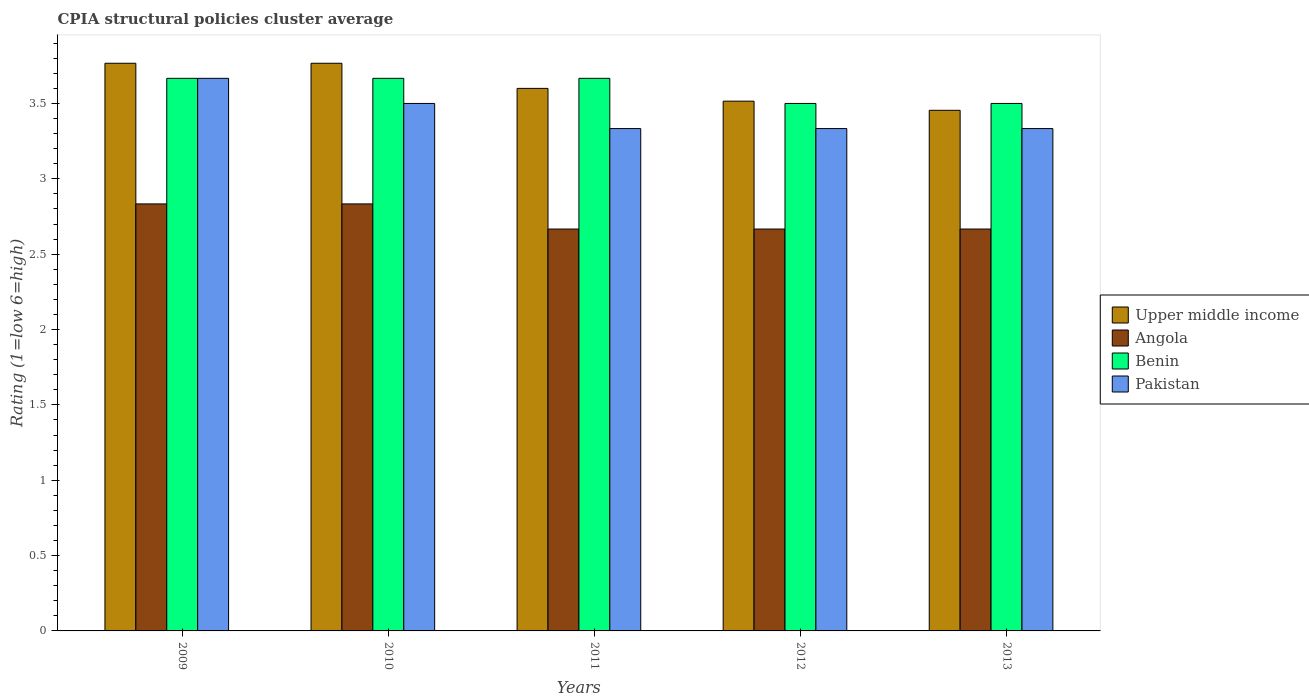How many different coloured bars are there?
Your response must be concise. 4. Are the number of bars per tick equal to the number of legend labels?
Your response must be concise. Yes. In how many cases, is the number of bars for a given year not equal to the number of legend labels?
Keep it short and to the point. 0. What is the CPIA rating in Angola in 2009?
Your answer should be very brief. 2.83. Across all years, what is the maximum CPIA rating in Angola?
Offer a terse response. 2.83. Across all years, what is the minimum CPIA rating in Upper middle income?
Provide a succinct answer. 3.45. In which year was the CPIA rating in Benin minimum?
Offer a terse response. 2012. What is the total CPIA rating in Upper middle income in the graph?
Give a very brief answer. 18.1. What is the difference between the CPIA rating in Angola in 2009 and that in 2013?
Keep it short and to the point. 0.17. What is the average CPIA rating in Pakistan per year?
Provide a short and direct response. 3.43. In the year 2009, what is the difference between the CPIA rating in Angola and CPIA rating in Benin?
Provide a succinct answer. -0.83. What is the ratio of the CPIA rating in Angola in 2011 to that in 2013?
Ensure brevity in your answer.  1. Is the CPIA rating in Angola in 2012 less than that in 2013?
Give a very brief answer. No. Is the difference between the CPIA rating in Angola in 2009 and 2010 greater than the difference between the CPIA rating in Benin in 2009 and 2010?
Provide a succinct answer. No. What is the difference between the highest and the lowest CPIA rating in Upper middle income?
Keep it short and to the point. 0.31. What does the 3rd bar from the left in 2011 represents?
Make the answer very short. Benin. What does the 3rd bar from the right in 2011 represents?
Your response must be concise. Angola. Is it the case that in every year, the sum of the CPIA rating in Benin and CPIA rating in Angola is greater than the CPIA rating in Pakistan?
Provide a short and direct response. Yes. What is the difference between two consecutive major ticks on the Y-axis?
Give a very brief answer. 0.5. Does the graph contain grids?
Your response must be concise. No. Where does the legend appear in the graph?
Ensure brevity in your answer.  Center right. How are the legend labels stacked?
Your answer should be compact. Vertical. What is the title of the graph?
Ensure brevity in your answer.  CPIA structural policies cluster average. What is the label or title of the X-axis?
Ensure brevity in your answer.  Years. What is the label or title of the Y-axis?
Your response must be concise. Rating (1=low 6=high). What is the Rating (1=low 6=high) in Upper middle income in 2009?
Ensure brevity in your answer.  3.77. What is the Rating (1=low 6=high) of Angola in 2009?
Your response must be concise. 2.83. What is the Rating (1=low 6=high) in Benin in 2009?
Provide a short and direct response. 3.67. What is the Rating (1=low 6=high) in Pakistan in 2009?
Your answer should be compact. 3.67. What is the Rating (1=low 6=high) in Upper middle income in 2010?
Your response must be concise. 3.77. What is the Rating (1=low 6=high) of Angola in 2010?
Offer a terse response. 2.83. What is the Rating (1=low 6=high) of Benin in 2010?
Provide a succinct answer. 3.67. What is the Rating (1=low 6=high) of Angola in 2011?
Offer a terse response. 2.67. What is the Rating (1=low 6=high) of Benin in 2011?
Offer a terse response. 3.67. What is the Rating (1=low 6=high) in Pakistan in 2011?
Offer a terse response. 3.33. What is the Rating (1=low 6=high) of Upper middle income in 2012?
Your answer should be very brief. 3.52. What is the Rating (1=low 6=high) of Angola in 2012?
Provide a short and direct response. 2.67. What is the Rating (1=low 6=high) in Benin in 2012?
Offer a terse response. 3.5. What is the Rating (1=low 6=high) in Pakistan in 2012?
Make the answer very short. 3.33. What is the Rating (1=low 6=high) of Upper middle income in 2013?
Keep it short and to the point. 3.45. What is the Rating (1=low 6=high) of Angola in 2013?
Make the answer very short. 2.67. What is the Rating (1=low 6=high) of Pakistan in 2013?
Your answer should be very brief. 3.33. Across all years, what is the maximum Rating (1=low 6=high) of Upper middle income?
Make the answer very short. 3.77. Across all years, what is the maximum Rating (1=low 6=high) of Angola?
Offer a terse response. 2.83. Across all years, what is the maximum Rating (1=low 6=high) of Benin?
Give a very brief answer. 3.67. Across all years, what is the maximum Rating (1=low 6=high) in Pakistan?
Offer a very short reply. 3.67. Across all years, what is the minimum Rating (1=low 6=high) in Upper middle income?
Your answer should be compact. 3.45. Across all years, what is the minimum Rating (1=low 6=high) of Angola?
Keep it short and to the point. 2.67. Across all years, what is the minimum Rating (1=low 6=high) of Benin?
Give a very brief answer. 3.5. Across all years, what is the minimum Rating (1=low 6=high) in Pakistan?
Make the answer very short. 3.33. What is the total Rating (1=low 6=high) of Upper middle income in the graph?
Provide a short and direct response. 18.1. What is the total Rating (1=low 6=high) of Angola in the graph?
Provide a short and direct response. 13.67. What is the total Rating (1=low 6=high) in Pakistan in the graph?
Offer a terse response. 17.17. What is the difference between the Rating (1=low 6=high) of Angola in 2009 and that in 2010?
Make the answer very short. 0. What is the difference between the Rating (1=low 6=high) of Benin in 2009 and that in 2010?
Offer a terse response. 0. What is the difference between the Rating (1=low 6=high) in Pakistan in 2009 and that in 2010?
Your response must be concise. 0.17. What is the difference between the Rating (1=low 6=high) in Upper middle income in 2009 and that in 2012?
Give a very brief answer. 0.25. What is the difference between the Rating (1=low 6=high) in Pakistan in 2009 and that in 2012?
Ensure brevity in your answer.  0.33. What is the difference between the Rating (1=low 6=high) of Upper middle income in 2009 and that in 2013?
Provide a succinct answer. 0.31. What is the difference between the Rating (1=low 6=high) in Angola in 2009 and that in 2013?
Your answer should be very brief. 0.17. What is the difference between the Rating (1=low 6=high) in Pakistan in 2009 and that in 2013?
Provide a short and direct response. 0.33. What is the difference between the Rating (1=low 6=high) in Upper middle income in 2010 and that in 2011?
Give a very brief answer. 0.17. What is the difference between the Rating (1=low 6=high) in Pakistan in 2010 and that in 2011?
Offer a terse response. 0.17. What is the difference between the Rating (1=low 6=high) of Upper middle income in 2010 and that in 2012?
Provide a short and direct response. 0.25. What is the difference between the Rating (1=low 6=high) in Angola in 2010 and that in 2012?
Keep it short and to the point. 0.17. What is the difference between the Rating (1=low 6=high) of Upper middle income in 2010 and that in 2013?
Your answer should be compact. 0.31. What is the difference between the Rating (1=low 6=high) in Angola in 2010 and that in 2013?
Give a very brief answer. 0.17. What is the difference between the Rating (1=low 6=high) of Benin in 2010 and that in 2013?
Your answer should be compact. 0.17. What is the difference between the Rating (1=low 6=high) in Pakistan in 2010 and that in 2013?
Provide a short and direct response. 0.17. What is the difference between the Rating (1=low 6=high) in Upper middle income in 2011 and that in 2012?
Provide a short and direct response. 0.08. What is the difference between the Rating (1=low 6=high) in Angola in 2011 and that in 2012?
Make the answer very short. 0. What is the difference between the Rating (1=low 6=high) in Benin in 2011 and that in 2012?
Provide a short and direct response. 0.17. What is the difference between the Rating (1=low 6=high) of Upper middle income in 2011 and that in 2013?
Provide a succinct answer. 0.15. What is the difference between the Rating (1=low 6=high) in Angola in 2011 and that in 2013?
Offer a terse response. 0. What is the difference between the Rating (1=low 6=high) of Benin in 2011 and that in 2013?
Offer a terse response. 0.17. What is the difference between the Rating (1=low 6=high) in Upper middle income in 2012 and that in 2013?
Your answer should be very brief. 0.06. What is the difference between the Rating (1=low 6=high) of Angola in 2012 and that in 2013?
Make the answer very short. 0. What is the difference between the Rating (1=low 6=high) of Pakistan in 2012 and that in 2013?
Offer a very short reply. 0. What is the difference between the Rating (1=low 6=high) in Upper middle income in 2009 and the Rating (1=low 6=high) in Benin in 2010?
Give a very brief answer. 0.1. What is the difference between the Rating (1=low 6=high) in Upper middle income in 2009 and the Rating (1=low 6=high) in Pakistan in 2010?
Give a very brief answer. 0.27. What is the difference between the Rating (1=low 6=high) in Angola in 2009 and the Rating (1=low 6=high) in Benin in 2010?
Your response must be concise. -0.83. What is the difference between the Rating (1=low 6=high) of Angola in 2009 and the Rating (1=low 6=high) of Pakistan in 2010?
Your response must be concise. -0.67. What is the difference between the Rating (1=low 6=high) in Upper middle income in 2009 and the Rating (1=low 6=high) in Angola in 2011?
Provide a short and direct response. 1.1. What is the difference between the Rating (1=low 6=high) of Upper middle income in 2009 and the Rating (1=low 6=high) of Pakistan in 2011?
Provide a succinct answer. 0.43. What is the difference between the Rating (1=low 6=high) of Angola in 2009 and the Rating (1=low 6=high) of Pakistan in 2011?
Ensure brevity in your answer.  -0.5. What is the difference between the Rating (1=low 6=high) of Benin in 2009 and the Rating (1=low 6=high) of Pakistan in 2011?
Your response must be concise. 0.33. What is the difference between the Rating (1=low 6=high) in Upper middle income in 2009 and the Rating (1=low 6=high) in Angola in 2012?
Offer a very short reply. 1.1. What is the difference between the Rating (1=low 6=high) of Upper middle income in 2009 and the Rating (1=low 6=high) of Benin in 2012?
Offer a terse response. 0.27. What is the difference between the Rating (1=low 6=high) in Upper middle income in 2009 and the Rating (1=low 6=high) in Pakistan in 2012?
Offer a terse response. 0.43. What is the difference between the Rating (1=low 6=high) of Angola in 2009 and the Rating (1=low 6=high) of Benin in 2012?
Provide a short and direct response. -0.67. What is the difference between the Rating (1=low 6=high) of Upper middle income in 2009 and the Rating (1=low 6=high) of Benin in 2013?
Keep it short and to the point. 0.27. What is the difference between the Rating (1=low 6=high) of Upper middle income in 2009 and the Rating (1=low 6=high) of Pakistan in 2013?
Give a very brief answer. 0.43. What is the difference between the Rating (1=low 6=high) of Upper middle income in 2010 and the Rating (1=low 6=high) of Pakistan in 2011?
Keep it short and to the point. 0.43. What is the difference between the Rating (1=low 6=high) of Angola in 2010 and the Rating (1=low 6=high) of Benin in 2011?
Give a very brief answer. -0.83. What is the difference between the Rating (1=low 6=high) in Angola in 2010 and the Rating (1=low 6=high) in Pakistan in 2011?
Make the answer very short. -0.5. What is the difference between the Rating (1=low 6=high) in Upper middle income in 2010 and the Rating (1=low 6=high) in Angola in 2012?
Offer a very short reply. 1.1. What is the difference between the Rating (1=low 6=high) of Upper middle income in 2010 and the Rating (1=low 6=high) of Benin in 2012?
Provide a succinct answer. 0.27. What is the difference between the Rating (1=low 6=high) of Upper middle income in 2010 and the Rating (1=low 6=high) of Pakistan in 2012?
Provide a succinct answer. 0.43. What is the difference between the Rating (1=low 6=high) in Angola in 2010 and the Rating (1=low 6=high) in Benin in 2012?
Ensure brevity in your answer.  -0.67. What is the difference between the Rating (1=low 6=high) in Angola in 2010 and the Rating (1=low 6=high) in Pakistan in 2012?
Your answer should be compact. -0.5. What is the difference between the Rating (1=low 6=high) of Upper middle income in 2010 and the Rating (1=low 6=high) of Benin in 2013?
Your answer should be very brief. 0.27. What is the difference between the Rating (1=low 6=high) in Upper middle income in 2010 and the Rating (1=low 6=high) in Pakistan in 2013?
Provide a succinct answer. 0.43. What is the difference between the Rating (1=low 6=high) in Angola in 2010 and the Rating (1=low 6=high) in Pakistan in 2013?
Your answer should be very brief. -0.5. What is the difference between the Rating (1=low 6=high) in Upper middle income in 2011 and the Rating (1=low 6=high) in Angola in 2012?
Provide a short and direct response. 0.93. What is the difference between the Rating (1=low 6=high) in Upper middle income in 2011 and the Rating (1=low 6=high) in Pakistan in 2012?
Give a very brief answer. 0.27. What is the difference between the Rating (1=low 6=high) of Angola in 2011 and the Rating (1=low 6=high) of Pakistan in 2012?
Your response must be concise. -0.67. What is the difference between the Rating (1=low 6=high) in Upper middle income in 2011 and the Rating (1=low 6=high) in Angola in 2013?
Your answer should be very brief. 0.93. What is the difference between the Rating (1=low 6=high) in Upper middle income in 2011 and the Rating (1=low 6=high) in Pakistan in 2013?
Ensure brevity in your answer.  0.27. What is the difference between the Rating (1=low 6=high) of Angola in 2011 and the Rating (1=low 6=high) of Benin in 2013?
Ensure brevity in your answer.  -0.83. What is the difference between the Rating (1=low 6=high) in Angola in 2011 and the Rating (1=low 6=high) in Pakistan in 2013?
Provide a short and direct response. -0.67. What is the difference between the Rating (1=low 6=high) of Benin in 2011 and the Rating (1=low 6=high) of Pakistan in 2013?
Your response must be concise. 0.33. What is the difference between the Rating (1=low 6=high) of Upper middle income in 2012 and the Rating (1=low 6=high) of Angola in 2013?
Make the answer very short. 0.85. What is the difference between the Rating (1=low 6=high) of Upper middle income in 2012 and the Rating (1=low 6=high) of Benin in 2013?
Ensure brevity in your answer.  0.02. What is the difference between the Rating (1=low 6=high) of Upper middle income in 2012 and the Rating (1=low 6=high) of Pakistan in 2013?
Offer a terse response. 0.18. What is the average Rating (1=low 6=high) in Upper middle income per year?
Your response must be concise. 3.62. What is the average Rating (1=low 6=high) of Angola per year?
Your answer should be very brief. 2.73. What is the average Rating (1=low 6=high) of Benin per year?
Provide a short and direct response. 3.6. What is the average Rating (1=low 6=high) of Pakistan per year?
Offer a terse response. 3.43. In the year 2010, what is the difference between the Rating (1=low 6=high) in Upper middle income and Rating (1=low 6=high) in Angola?
Offer a very short reply. 0.93. In the year 2010, what is the difference between the Rating (1=low 6=high) of Upper middle income and Rating (1=low 6=high) of Benin?
Your answer should be compact. 0.1. In the year 2010, what is the difference between the Rating (1=low 6=high) of Upper middle income and Rating (1=low 6=high) of Pakistan?
Provide a short and direct response. 0.27. In the year 2010, what is the difference between the Rating (1=low 6=high) in Angola and Rating (1=low 6=high) in Benin?
Make the answer very short. -0.83. In the year 2011, what is the difference between the Rating (1=low 6=high) of Upper middle income and Rating (1=low 6=high) of Benin?
Your answer should be compact. -0.07. In the year 2011, what is the difference between the Rating (1=low 6=high) in Upper middle income and Rating (1=low 6=high) in Pakistan?
Give a very brief answer. 0.27. In the year 2011, what is the difference between the Rating (1=low 6=high) of Benin and Rating (1=low 6=high) of Pakistan?
Offer a very short reply. 0.33. In the year 2012, what is the difference between the Rating (1=low 6=high) in Upper middle income and Rating (1=low 6=high) in Angola?
Offer a very short reply. 0.85. In the year 2012, what is the difference between the Rating (1=low 6=high) of Upper middle income and Rating (1=low 6=high) of Benin?
Keep it short and to the point. 0.02. In the year 2012, what is the difference between the Rating (1=low 6=high) of Upper middle income and Rating (1=low 6=high) of Pakistan?
Provide a succinct answer. 0.18. In the year 2012, what is the difference between the Rating (1=low 6=high) of Angola and Rating (1=low 6=high) of Benin?
Provide a succinct answer. -0.83. In the year 2013, what is the difference between the Rating (1=low 6=high) in Upper middle income and Rating (1=low 6=high) in Angola?
Your response must be concise. 0.79. In the year 2013, what is the difference between the Rating (1=low 6=high) in Upper middle income and Rating (1=low 6=high) in Benin?
Ensure brevity in your answer.  -0.05. In the year 2013, what is the difference between the Rating (1=low 6=high) of Upper middle income and Rating (1=low 6=high) of Pakistan?
Provide a short and direct response. 0.12. In the year 2013, what is the difference between the Rating (1=low 6=high) of Angola and Rating (1=low 6=high) of Benin?
Make the answer very short. -0.83. What is the ratio of the Rating (1=low 6=high) in Angola in 2009 to that in 2010?
Ensure brevity in your answer.  1. What is the ratio of the Rating (1=low 6=high) in Pakistan in 2009 to that in 2010?
Your answer should be very brief. 1.05. What is the ratio of the Rating (1=low 6=high) in Upper middle income in 2009 to that in 2011?
Your answer should be compact. 1.05. What is the ratio of the Rating (1=low 6=high) of Angola in 2009 to that in 2011?
Keep it short and to the point. 1.06. What is the ratio of the Rating (1=low 6=high) of Upper middle income in 2009 to that in 2012?
Offer a very short reply. 1.07. What is the ratio of the Rating (1=low 6=high) of Angola in 2009 to that in 2012?
Ensure brevity in your answer.  1.06. What is the ratio of the Rating (1=low 6=high) of Benin in 2009 to that in 2012?
Keep it short and to the point. 1.05. What is the ratio of the Rating (1=low 6=high) in Upper middle income in 2009 to that in 2013?
Your response must be concise. 1.09. What is the ratio of the Rating (1=low 6=high) of Angola in 2009 to that in 2013?
Keep it short and to the point. 1.06. What is the ratio of the Rating (1=low 6=high) in Benin in 2009 to that in 2013?
Give a very brief answer. 1.05. What is the ratio of the Rating (1=low 6=high) in Pakistan in 2009 to that in 2013?
Your response must be concise. 1.1. What is the ratio of the Rating (1=low 6=high) in Upper middle income in 2010 to that in 2011?
Provide a succinct answer. 1.05. What is the ratio of the Rating (1=low 6=high) of Angola in 2010 to that in 2011?
Offer a very short reply. 1.06. What is the ratio of the Rating (1=low 6=high) of Benin in 2010 to that in 2011?
Provide a short and direct response. 1. What is the ratio of the Rating (1=low 6=high) of Pakistan in 2010 to that in 2011?
Offer a very short reply. 1.05. What is the ratio of the Rating (1=low 6=high) of Upper middle income in 2010 to that in 2012?
Your response must be concise. 1.07. What is the ratio of the Rating (1=low 6=high) in Angola in 2010 to that in 2012?
Offer a terse response. 1.06. What is the ratio of the Rating (1=low 6=high) of Benin in 2010 to that in 2012?
Keep it short and to the point. 1.05. What is the ratio of the Rating (1=low 6=high) in Upper middle income in 2010 to that in 2013?
Provide a short and direct response. 1.09. What is the ratio of the Rating (1=low 6=high) of Angola in 2010 to that in 2013?
Provide a short and direct response. 1.06. What is the ratio of the Rating (1=low 6=high) in Benin in 2010 to that in 2013?
Give a very brief answer. 1.05. What is the ratio of the Rating (1=low 6=high) in Pakistan in 2010 to that in 2013?
Offer a very short reply. 1.05. What is the ratio of the Rating (1=low 6=high) of Upper middle income in 2011 to that in 2012?
Make the answer very short. 1.02. What is the ratio of the Rating (1=low 6=high) in Angola in 2011 to that in 2012?
Your answer should be compact. 1. What is the ratio of the Rating (1=low 6=high) of Benin in 2011 to that in 2012?
Make the answer very short. 1.05. What is the ratio of the Rating (1=low 6=high) in Pakistan in 2011 to that in 2012?
Your response must be concise. 1. What is the ratio of the Rating (1=low 6=high) of Upper middle income in 2011 to that in 2013?
Offer a terse response. 1.04. What is the ratio of the Rating (1=low 6=high) in Benin in 2011 to that in 2013?
Provide a short and direct response. 1.05. What is the ratio of the Rating (1=low 6=high) in Pakistan in 2011 to that in 2013?
Your response must be concise. 1. What is the ratio of the Rating (1=low 6=high) of Upper middle income in 2012 to that in 2013?
Ensure brevity in your answer.  1.02. What is the ratio of the Rating (1=low 6=high) in Angola in 2012 to that in 2013?
Your answer should be compact. 1. What is the ratio of the Rating (1=low 6=high) in Pakistan in 2012 to that in 2013?
Your response must be concise. 1. What is the difference between the highest and the second highest Rating (1=low 6=high) of Benin?
Your response must be concise. 0. What is the difference between the highest and the second highest Rating (1=low 6=high) of Pakistan?
Your response must be concise. 0.17. What is the difference between the highest and the lowest Rating (1=low 6=high) of Upper middle income?
Give a very brief answer. 0.31. What is the difference between the highest and the lowest Rating (1=low 6=high) in Angola?
Offer a very short reply. 0.17. What is the difference between the highest and the lowest Rating (1=low 6=high) of Benin?
Offer a terse response. 0.17. What is the difference between the highest and the lowest Rating (1=low 6=high) of Pakistan?
Your answer should be very brief. 0.33. 